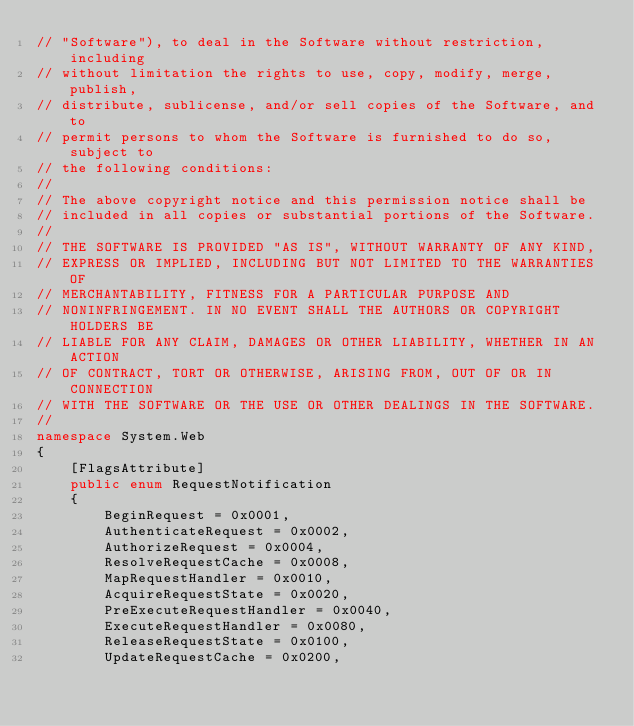<code> <loc_0><loc_0><loc_500><loc_500><_C#_>// "Software"), to deal in the Software without restriction, including
// without limitation the rights to use, copy, modify, merge, publish,
// distribute, sublicense, and/or sell copies of the Software, and to
// permit persons to whom the Software is furnished to do so, subject to
// the following conditions:
// 
// The above copyright notice and this permission notice shall be
// included in all copies or substantial portions of the Software.
// 
// THE SOFTWARE IS PROVIDED "AS IS", WITHOUT WARRANTY OF ANY KIND,
// EXPRESS OR IMPLIED, INCLUDING BUT NOT LIMITED TO THE WARRANTIES OF
// MERCHANTABILITY, FITNESS FOR A PARTICULAR PURPOSE AND
// NONINFRINGEMENT. IN NO EVENT SHALL THE AUTHORS OR COPYRIGHT HOLDERS BE
// LIABLE FOR ANY CLAIM, DAMAGES OR OTHER LIABILITY, WHETHER IN AN ACTION
// OF CONTRACT, TORT OR OTHERWISE, ARISING FROM, OUT OF OR IN CONNECTION
// WITH THE SOFTWARE OR THE USE OR OTHER DEALINGS IN THE SOFTWARE.
//
namespace System.Web 
{
	[FlagsAttribute]
	public enum RequestNotification
	{
		BeginRequest = 0x0001,
		AuthenticateRequest = 0x0002,
		AuthorizeRequest = 0x0004,
		ResolveRequestCache = 0x0008,
		MapRequestHandler = 0x0010,
		AcquireRequestState = 0x0020,
		PreExecuteRequestHandler = 0x0040,
		ExecuteRequestHandler = 0x0080,
		ReleaseRequestState = 0x0100,
		UpdateRequestCache = 0x0200,</code> 